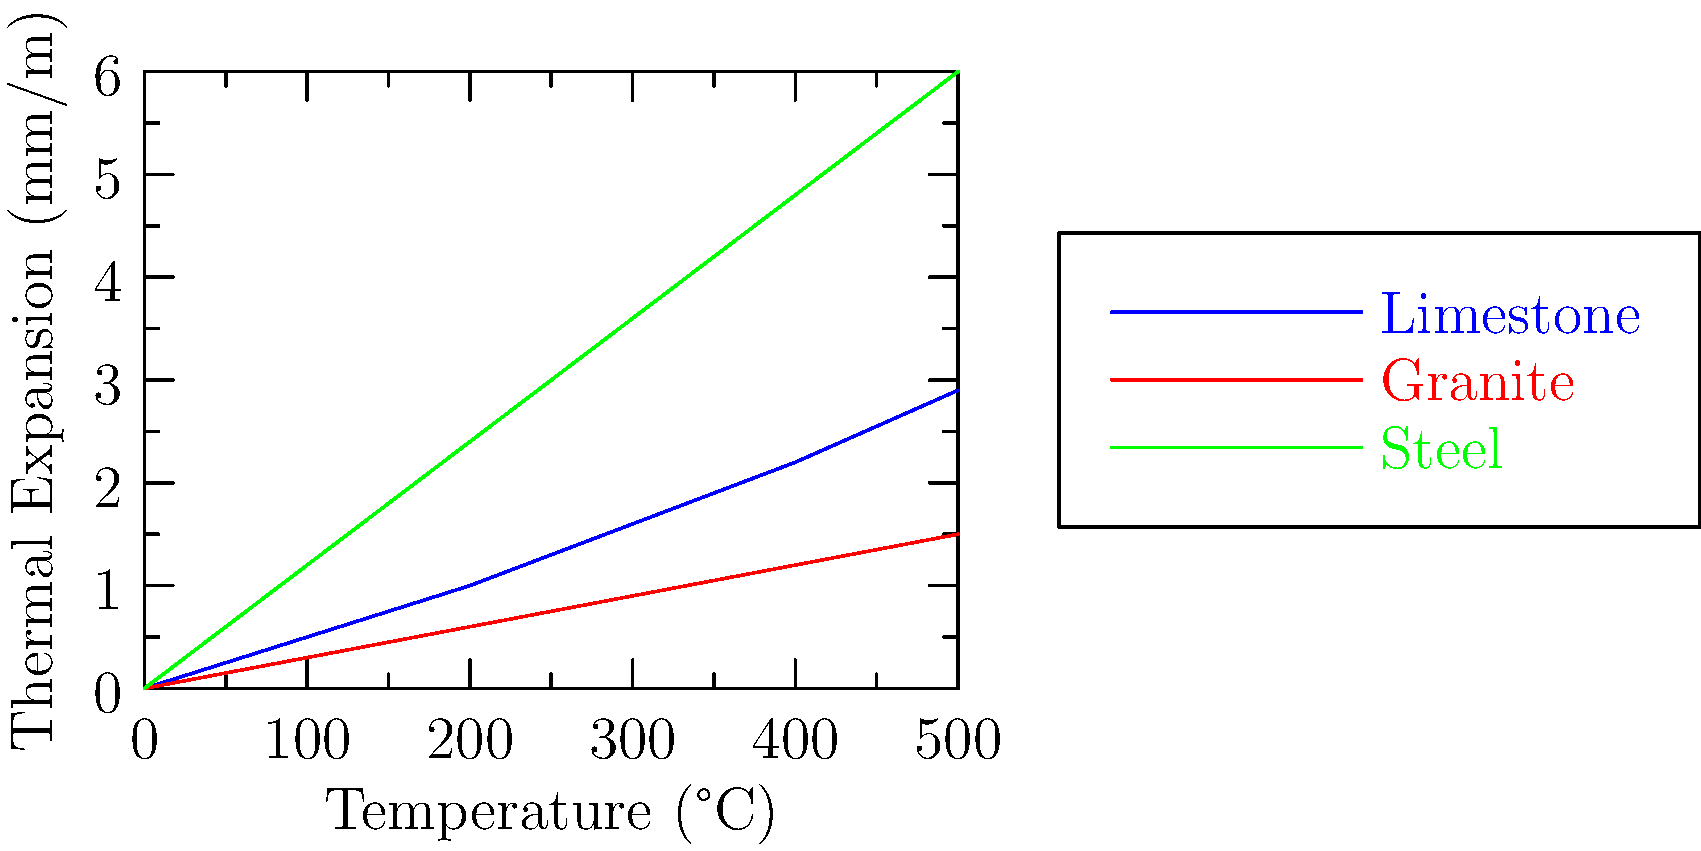In the restoration of Glamis Castle, a historic structure in Angus, you're tasked with choosing materials for a new support beam. Given the graph showing thermal expansion characteristics of different materials, which would be the most suitable for maintaining structural integrity across a wide temperature range, and why? To determine the most suitable material for the support beam, we need to analyze the thermal expansion characteristics of each material:

1. Understand the graph:
   - X-axis represents temperature (°C)
   - Y-axis represents thermal expansion (mm/m)
   - Three materials are shown: Limestone (blue), Granite (red), and Steel (green)

2. Compare the slopes of the lines:
   - Steeper slope indicates greater thermal expansion with temperature change
   - Steel has the steepest slope, followed by Limestone, then Granite

3. Consider the temperature range:
   - The graph shows expansion from 0°C to 500°C
   - Historic buildings experience significant temperature variations

4. Analyze material properties:
   - Granite shows the least thermal expansion across the temperature range
   - At 500°C, expansions are approximately:
     Granite: 1.5 mm/m
     Limestone: 2.9 mm/m
     Steel: 6.0 mm/m

5. Consider structural implications:
   - Less expansion means less stress on surrounding structures
   - Consistent behavior across temperature range is desirable for long-term stability

6. Historical context:
   - Granite is a traditional building material in Scotland
   - It aligns with the historical authenticity of Glamis Castle

Therefore, Granite would be the most suitable material for the support beam due to its minimal thermal expansion, ensuring the least stress on the structure across a wide temperature range while maintaining historical authenticity.
Answer: Granite, due to minimal thermal expansion 